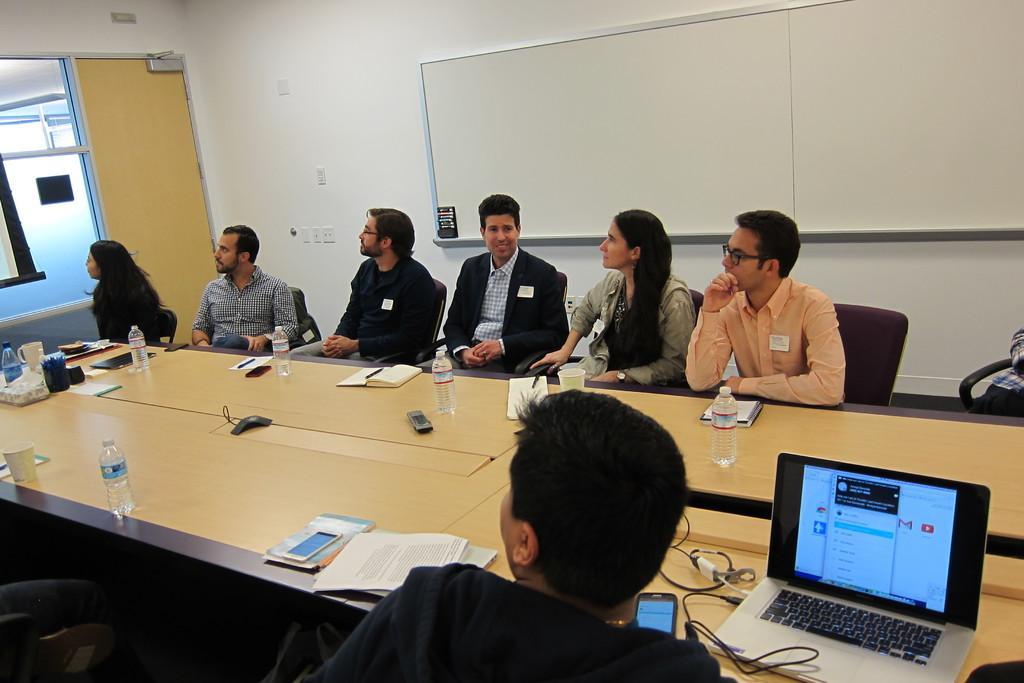Could you give a brief overview of what you see in this image? In this image we can see a group of people sitting in chairs. And we can see the bottles, laptop and some objects on the table. And we can see the door, window. And we can see the one writing board. And we can see the wall. 